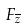Convert formula to latex. <formula><loc_0><loc_0><loc_500><loc_500>F _ { \overline { z } }</formula> 